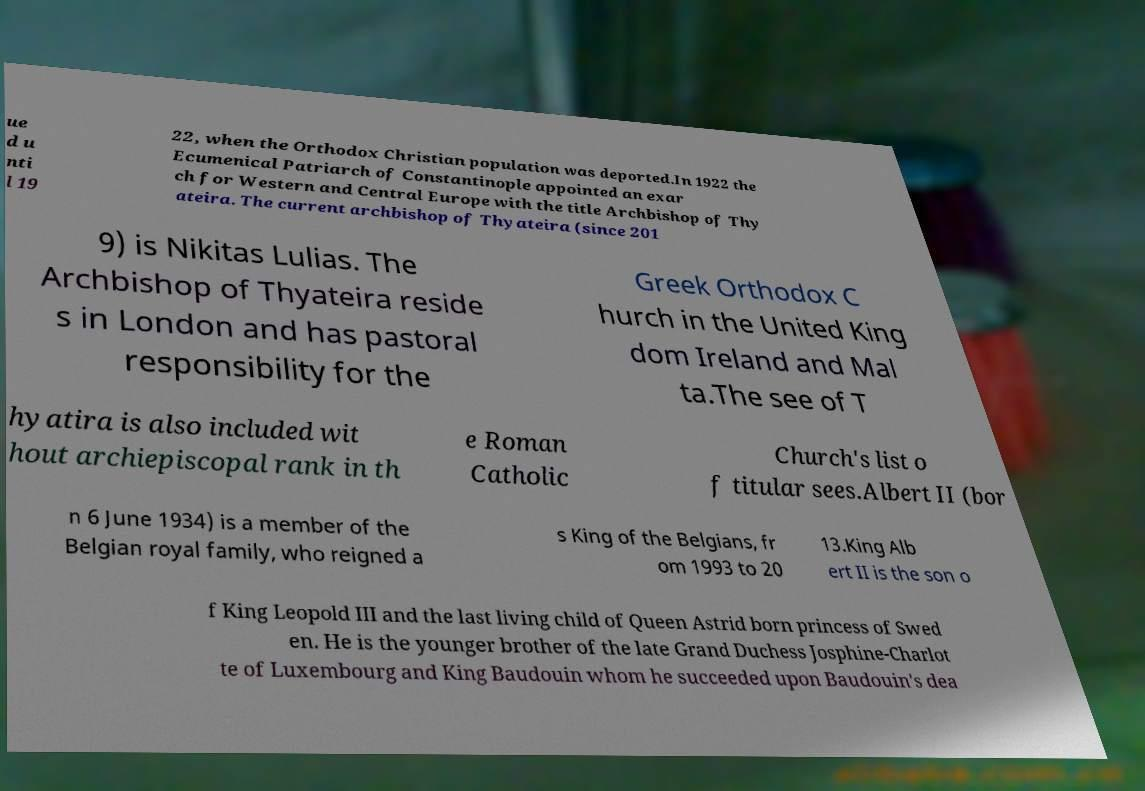For documentation purposes, I need the text within this image transcribed. Could you provide that? ue d u nti l 19 22, when the Orthodox Christian population was deported.In 1922 the Ecumenical Patriarch of Constantinople appointed an exar ch for Western and Central Europe with the title Archbishop of Thy ateira. The current archbishop of Thyateira (since 201 9) is Nikitas Lulias. The Archbishop of Thyateira reside s in London and has pastoral responsibility for the Greek Orthodox C hurch in the United King dom Ireland and Mal ta.The see of T hyatira is also included wit hout archiepiscopal rank in th e Roman Catholic Church's list o f titular sees.Albert II (bor n 6 June 1934) is a member of the Belgian royal family, who reigned a s King of the Belgians, fr om 1993 to 20 13.King Alb ert II is the son o f King Leopold III and the last living child of Queen Astrid born princess of Swed en. He is the younger brother of the late Grand Duchess Josphine-Charlot te of Luxembourg and King Baudouin whom he succeeded upon Baudouin's dea 